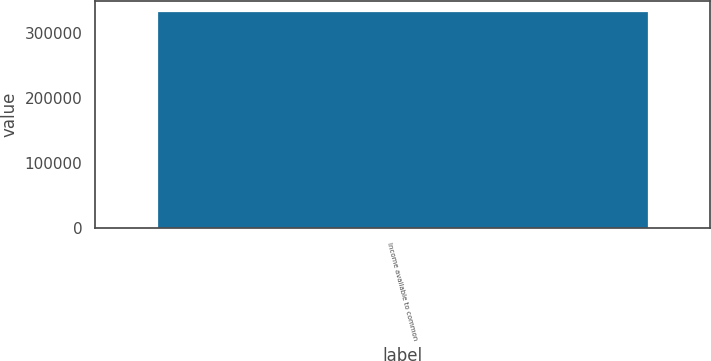Convert chart to OTSL. <chart><loc_0><loc_0><loc_500><loc_500><bar_chart><fcel>Income available to common<nl><fcel>333572<nl></chart> 